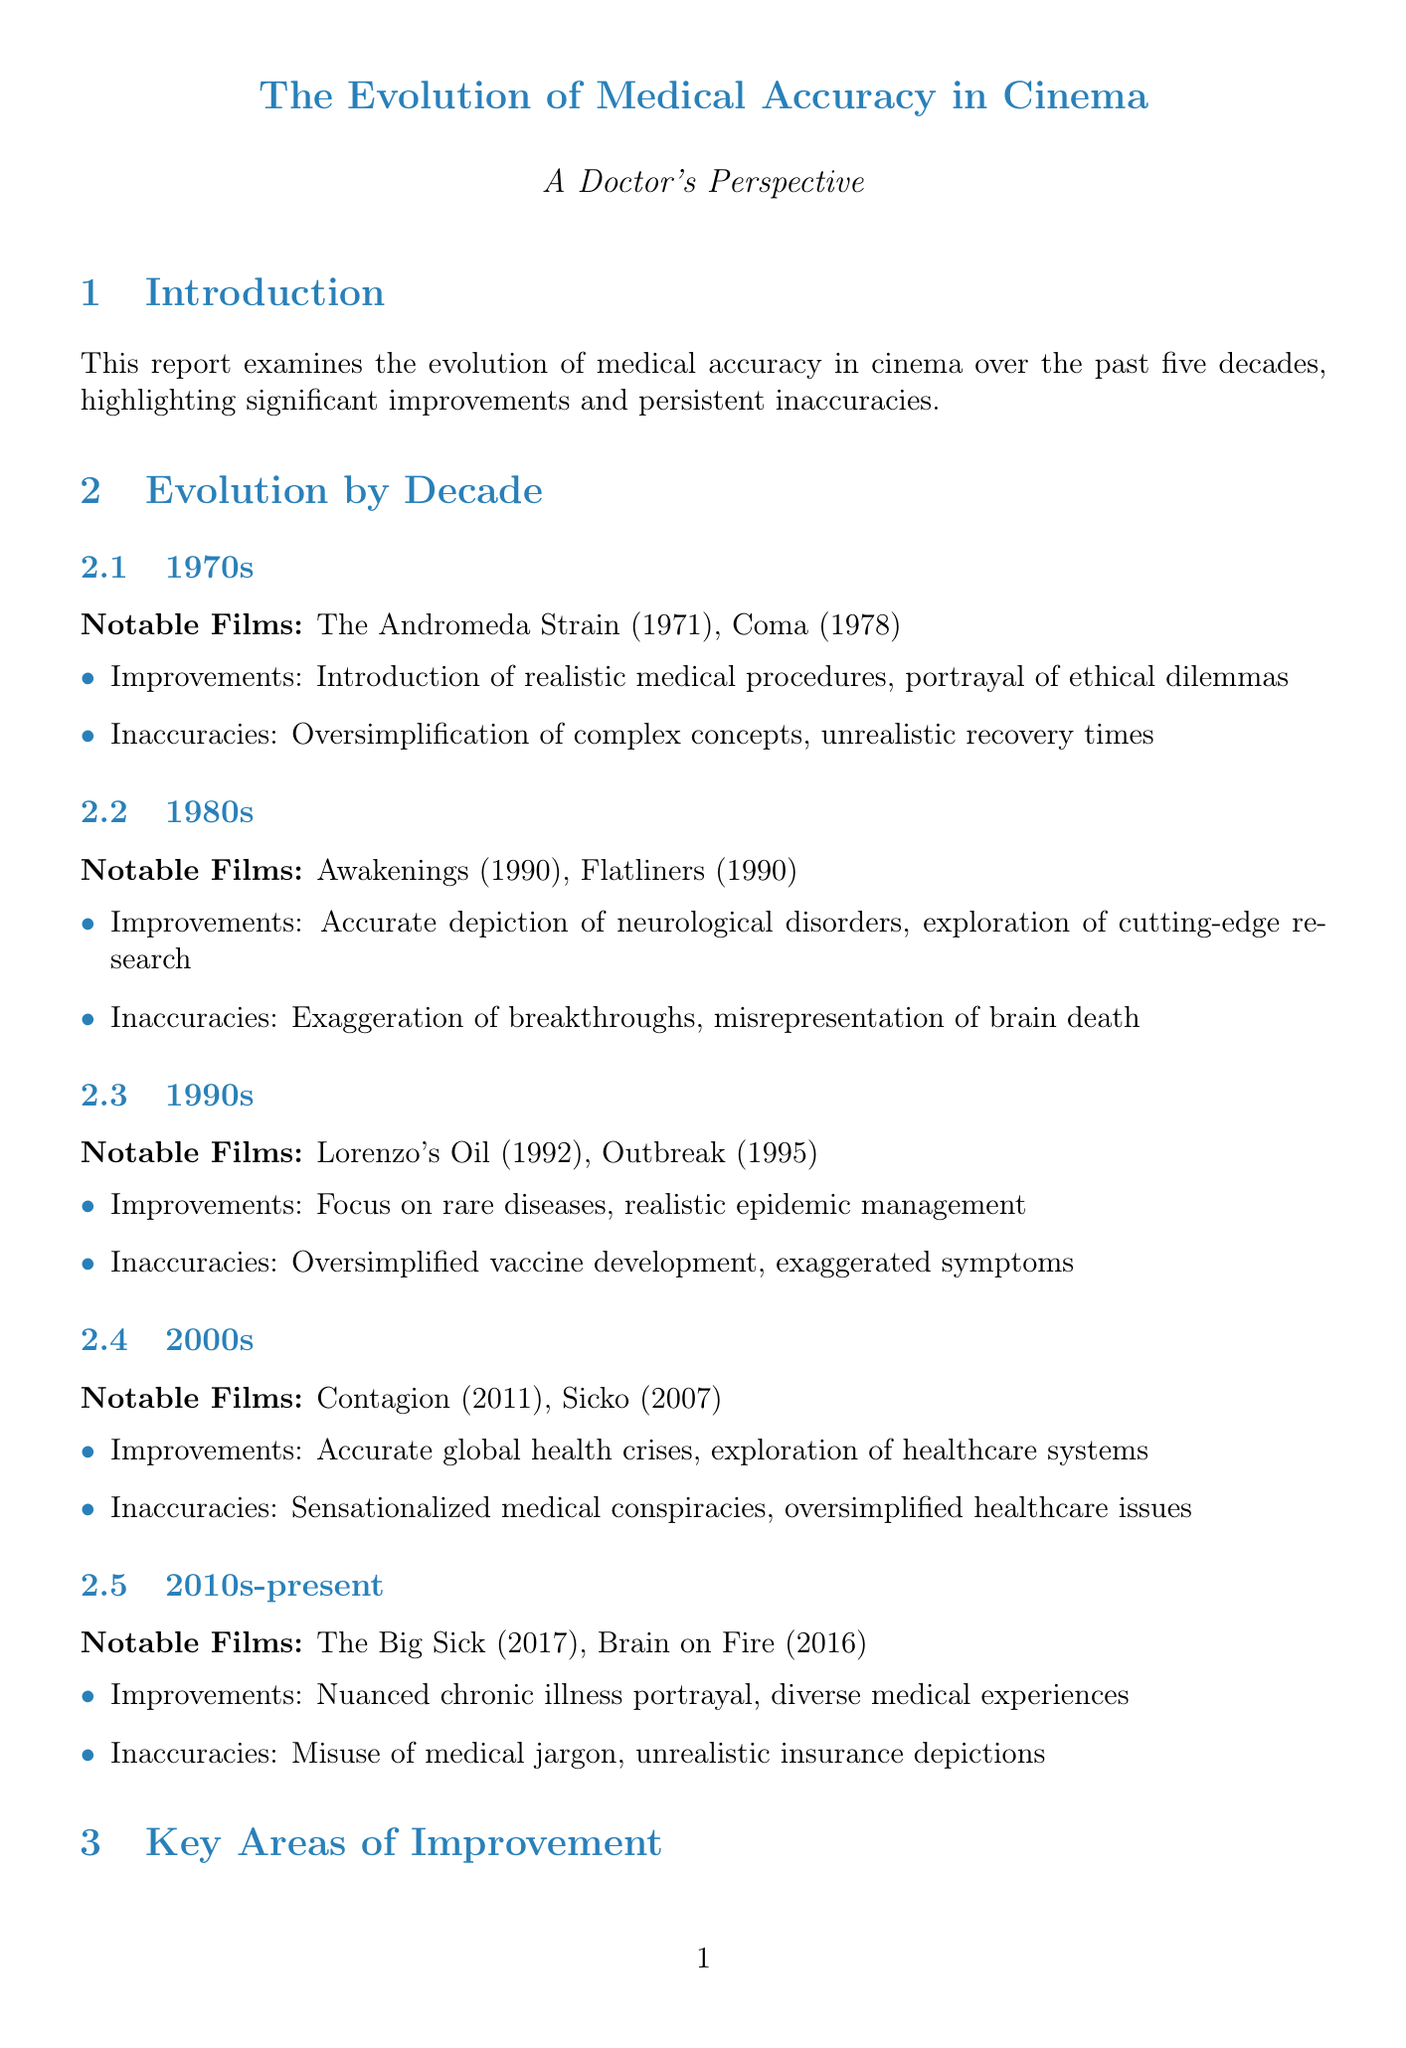What notable film from the 1980s explored neurological disorders? The notable film from the 1980s that explored neurological disorders is mentioned in the document, which is "Awakenings (1990)."
Answer: Awakenings (1990) What are two significant improvements in medical accuracy from the 2000s? The document lists improvements such as "more accurate depiction of global health crises" and "exploration of healthcare systems and policies."
Answer: Accurate depiction of global health crises, exploration of healthcare systems What is one key area of improvement mentioned in the report? The report highlights several key areas of improvement, one of which is "anatomical accuracy in surgical scenes."
Answer: Anatomical accuracy in surgical scenes Which medical consultant is noted for working on "Grey's Anatomy"? The notable consultant mentioned for "Grey's Anatomy" in the document is Dr. Zoanne Clack.
Answer: Dr. Zoanne Clack What is a persistent inaccuracy in medical representations in cinema according to the report? The document notes numerous persistent inaccuracies, including "unrealistic CPR success rates."
Answer: Unrealistic CPR success rates How has cinema positively impacted public perception of medical conditions? The report states that one positive effect is "increased awareness of certain medical conditions."
Answer: Increased awareness of certain medical conditions What film is recommended for its medical accuracy released in 2001? According to the document, "Wit (2001)" is recommended for its medical accuracy.
Answer: Wit (2001) What future trend in medical representation in cinema involves filmmakers? The document notes a future trend of "increased collaboration between filmmakers and medical professionals."
Answer: Increased collaboration between filmmakers and medical professionals 